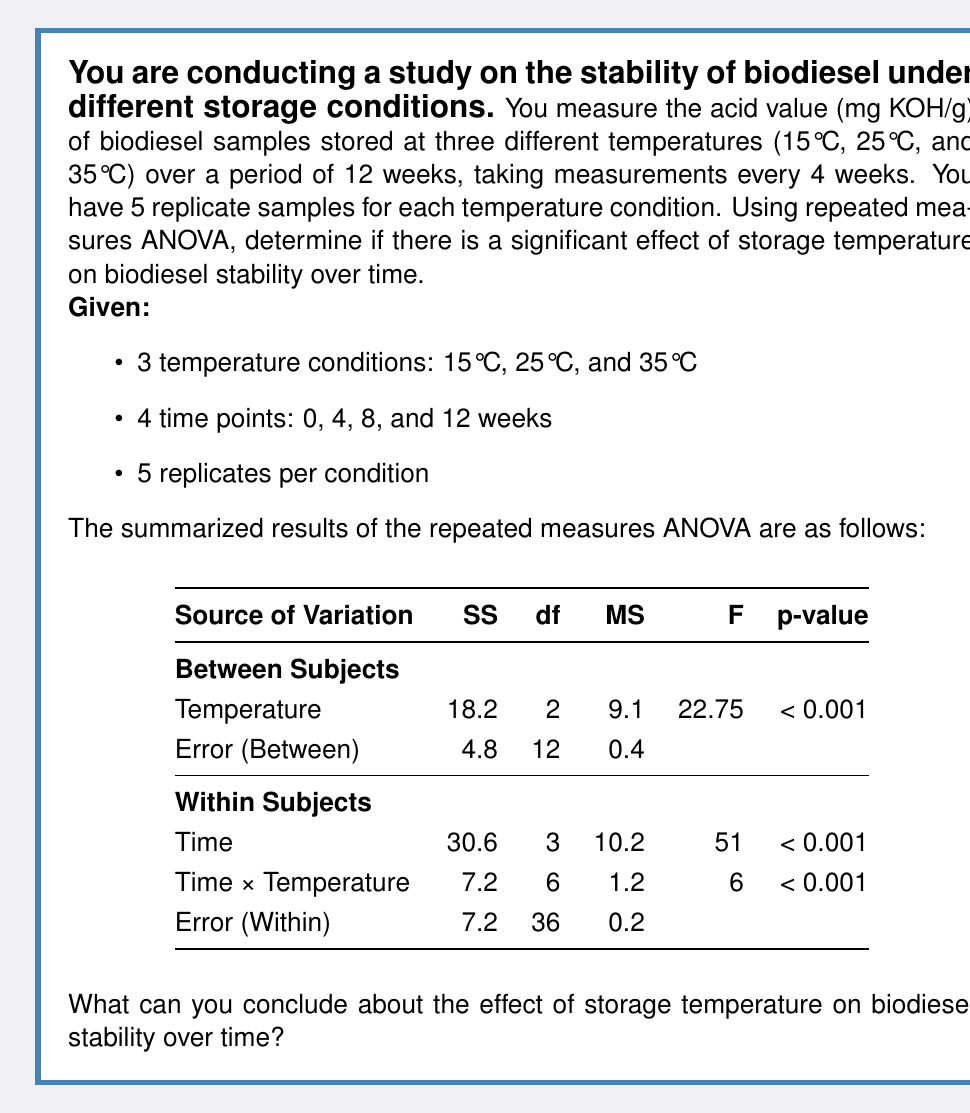Can you solve this math problem? To interpret the results of the repeated measures ANOVA, we need to examine the F-values and p-values for each source of variation:

1. Temperature effect:
   - F(2, 12) = 22.75, p < 0.001
   This indicates a significant main effect of temperature on biodiesel stability.

2. Time effect:
   - F(3, 36) = 51, p < 0.001
   This shows a significant main effect of time on biodiesel stability.

3. Time × Temperature interaction:
   - F(6, 36) = 6, p < 0.001
   This reveals a significant interaction between time and temperature.

To interpret these results:

1. The significant main effect of temperature (p < 0.001) suggests that storage temperature has a significant impact on biodiesel stability, regardless of time.

2. The significant main effect of time (p < 0.001) indicates that biodiesel stability changes significantly over the 12-week period, regardless of temperature.

3. The significant interaction between time and temperature (p < 0.001) implies that the effect of temperature on biodiesel stability changes over time, or conversely, the effect of time on biodiesel stability differs depending on the storage temperature.

To visualize this interaction, we could plot the acid value against time for each temperature condition, which would likely show different slopes or patterns for each temperature.

The F-values provide information about the strength of the effects:

- The time effect has the largest F-value (51), suggesting it has the strongest influence on biodiesel stability.
- The temperature effect has the second-largest F-value (22.75), indicating it also has a substantial impact.
- The interaction effect has a smaller but still significant F-value (6), showing that the combined effect of time and temperature is important but not as strong as the individual main effects.
Answer: Based on the repeated measures ANOVA results, we can conclude that:

1. Storage temperature has a significant effect on biodiesel stability (F(2, 12) = 22.75, p < 0.001).
2. Biodiesel stability changes significantly over time (F(3, 36) = 51, p < 0.001).
3. There is a significant interaction between storage temperature and time (F(6, 36) = 6, p < 0.001), indicating that the effect of temperature on biodiesel stability varies over time.

These findings suggest that both storage temperature and duration play crucial roles in maintaining biodiesel stability, and their effects are interdependent. The results emphasize the importance of considering both factors when designing storage protocols for biodiesel. 